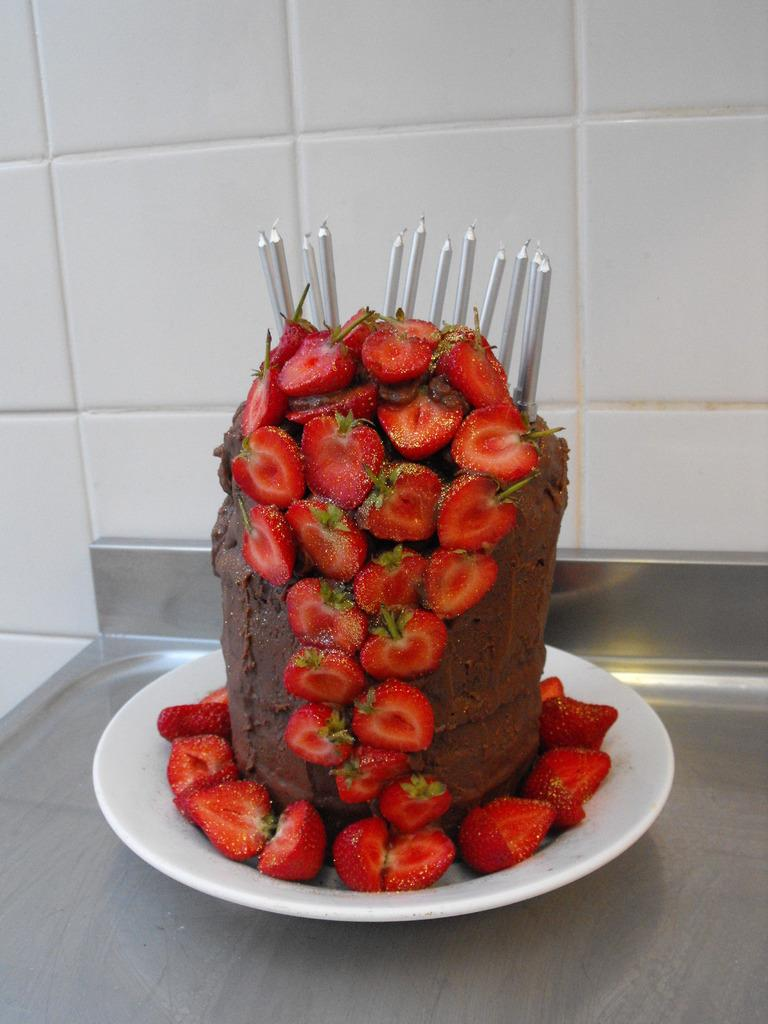What is the main subject of the image? There is a cake in the image. What is the cake placed on? The cake is on a white-colored plant. How is the cake decorated? The cake is decorated with strawberries. Are there any additional items on the cake? Yes, the cake has candles on it. What is the cake resting on? The cake is on a plate. What is the plate is placed on? The plate is on a metal surface. What can be seen in the background of the image? There is a wall in the background of the image. What type of loaf is being served at the cemetery in the image? There is no loaf or cemetery present in the image; it features a cake on a white-colored plant. What kind of plant is growing on the cake in the image? The image does not show a plant growing on the cake; it shows a cake on a white-colored plant. 